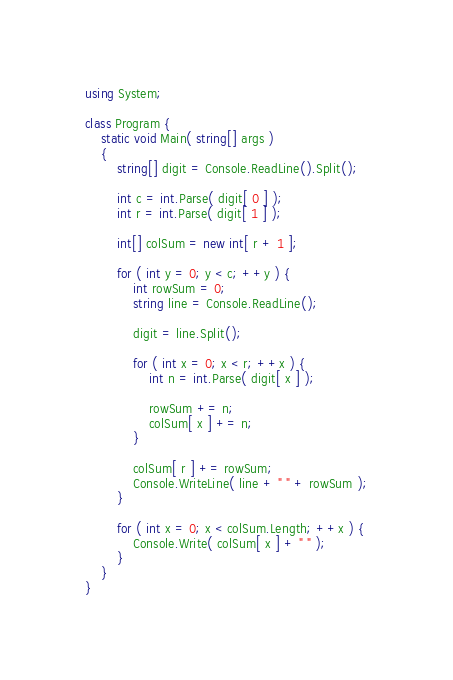Convert code to text. <code><loc_0><loc_0><loc_500><loc_500><_C#_>using System;

class Program {
    static void Main( string[] args )
    {
        string[] digit = Console.ReadLine().Split();

        int c = int.Parse( digit[ 0 ] );
        int r = int.Parse( digit[ 1 ] );

        int[] colSum = new int[ r + 1 ];

        for ( int y = 0; y < c; ++y ) {
            int rowSum = 0;
            string line = Console.ReadLine();

            digit = line.Split();

            for ( int x = 0; x < r; ++x ) {
                int n = int.Parse( digit[ x ] );

                rowSum += n;
                colSum[ x ] += n;
            }

            colSum[ r ] += rowSum;
            Console.WriteLine( line + " " + rowSum );
        }

        for ( int x = 0; x < colSum.Length; ++x ) {
            Console.Write( colSum[ x ] + " " );
        }
    }
}</code> 